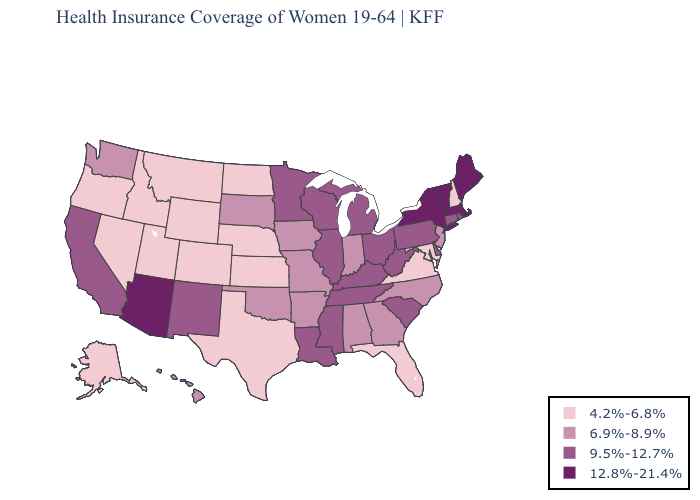Which states have the lowest value in the Northeast?
Be succinct. New Hampshire. Does the first symbol in the legend represent the smallest category?
Quick response, please. Yes. Among the states that border Colorado , which have the lowest value?
Keep it brief. Kansas, Nebraska, Utah, Wyoming. What is the highest value in the South ?
Concise answer only. 9.5%-12.7%. What is the highest value in the USA?
Write a very short answer. 12.8%-21.4%. Name the states that have a value in the range 9.5%-12.7%?
Write a very short answer. California, Connecticut, Delaware, Illinois, Kentucky, Louisiana, Michigan, Minnesota, Mississippi, New Mexico, Ohio, Pennsylvania, Rhode Island, South Carolina, Tennessee, West Virginia, Wisconsin. Which states have the lowest value in the West?
Give a very brief answer. Alaska, Colorado, Idaho, Montana, Nevada, Oregon, Utah, Wyoming. What is the value of Montana?
Give a very brief answer. 4.2%-6.8%. Name the states that have a value in the range 6.9%-8.9%?
Concise answer only. Alabama, Arkansas, Georgia, Hawaii, Indiana, Iowa, Missouri, New Jersey, North Carolina, Oklahoma, South Dakota, Washington. Is the legend a continuous bar?
Short answer required. No. Name the states that have a value in the range 4.2%-6.8%?
Be succinct. Alaska, Colorado, Florida, Idaho, Kansas, Maryland, Montana, Nebraska, Nevada, New Hampshire, North Dakota, Oregon, Texas, Utah, Virginia, Wyoming. Which states have the lowest value in the South?
Be succinct. Florida, Maryland, Texas, Virginia. Name the states that have a value in the range 6.9%-8.9%?
Concise answer only. Alabama, Arkansas, Georgia, Hawaii, Indiana, Iowa, Missouri, New Jersey, North Carolina, Oklahoma, South Dakota, Washington. Does Arkansas have the same value as Montana?
Short answer required. No. What is the lowest value in the West?
Quick response, please. 4.2%-6.8%. 